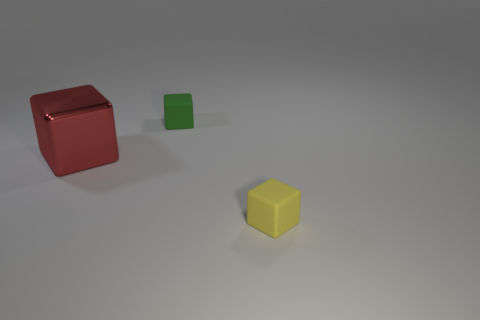Add 3 green rubber cubes. How many objects exist? 6 Subtract 2 blocks. How many blocks are left? 1 Subtract all green blocks. How many blocks are left? 2 Subtract all red blocks. How many blocks are left? 2 Subtract all gray blocks. Subtract all blue cylinders. How many blocks are left? 3 Subtract all yellow cylinders. How many green cubes are left? 1 Subtract all cubes. Subtract all big yellow metallic cylinders. How many objects are left? 0 Add 1 big metal cubes. How many big metal cubes are left? 2 Add 3 large red metallic blocks. How many large red metallic blocks exist? 4 Subtract 0 brown spheres. How many objects are left? 3 